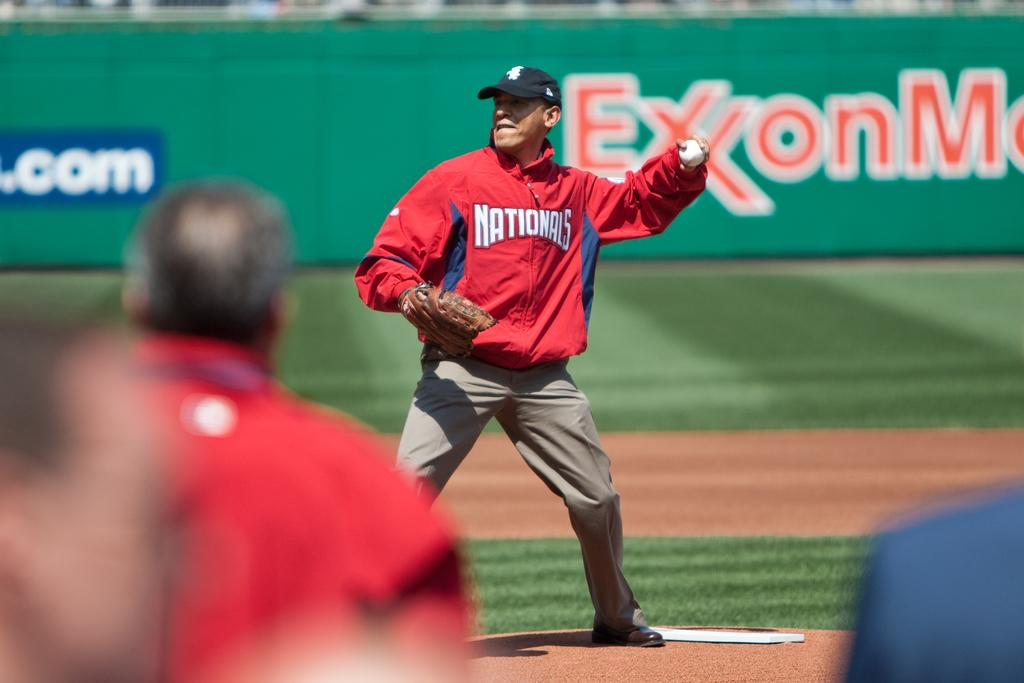<image>
Create a compact narrative representing the image presented. A man wearing a Nationals jacket is about to throw a baseball. 